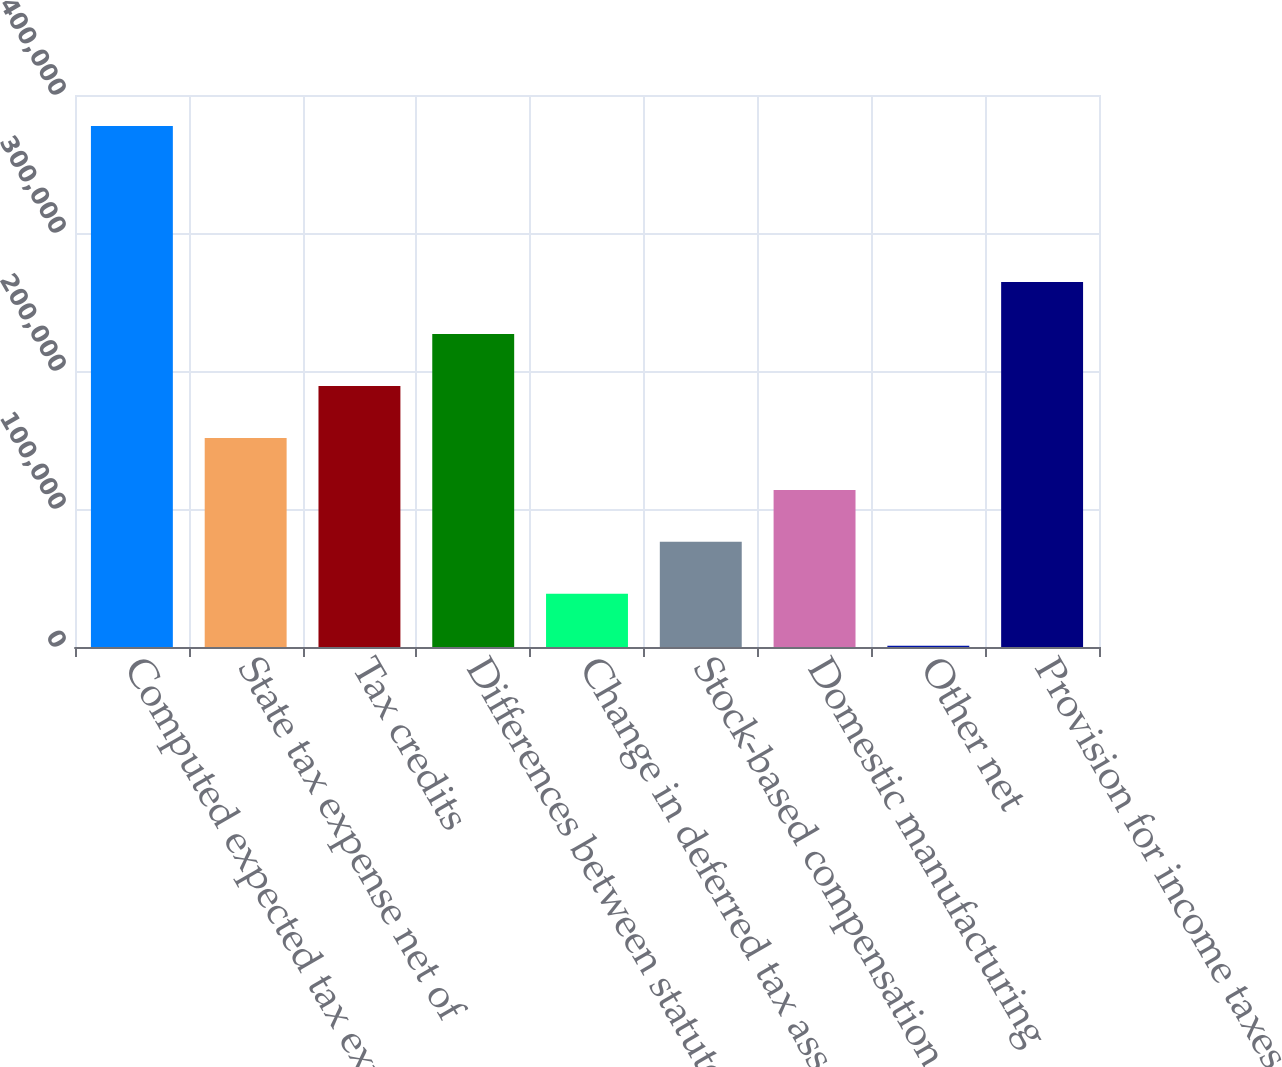Convert chart to OTSL. <chart><loc_0><loc_0><loc_500><loc_500><bar_chart><fcel>Computed expected tax expense<fcel>State tax expense net of<fcel>Tax credits<fcel>Differences between statutory<fcel>Change in deferred tax asset<fcel>Stock-based compensation (net<fcel>Domestic manufacturing<fcel>Other net<fcel>Provision for income taxes<nl><fcel>377478<fcel>151513<fcel>189174<fcel>226835<fcel>38530.8<fcel>76191.6<fcel>113852<fcel>870<fcel>264496<nl></chart> 